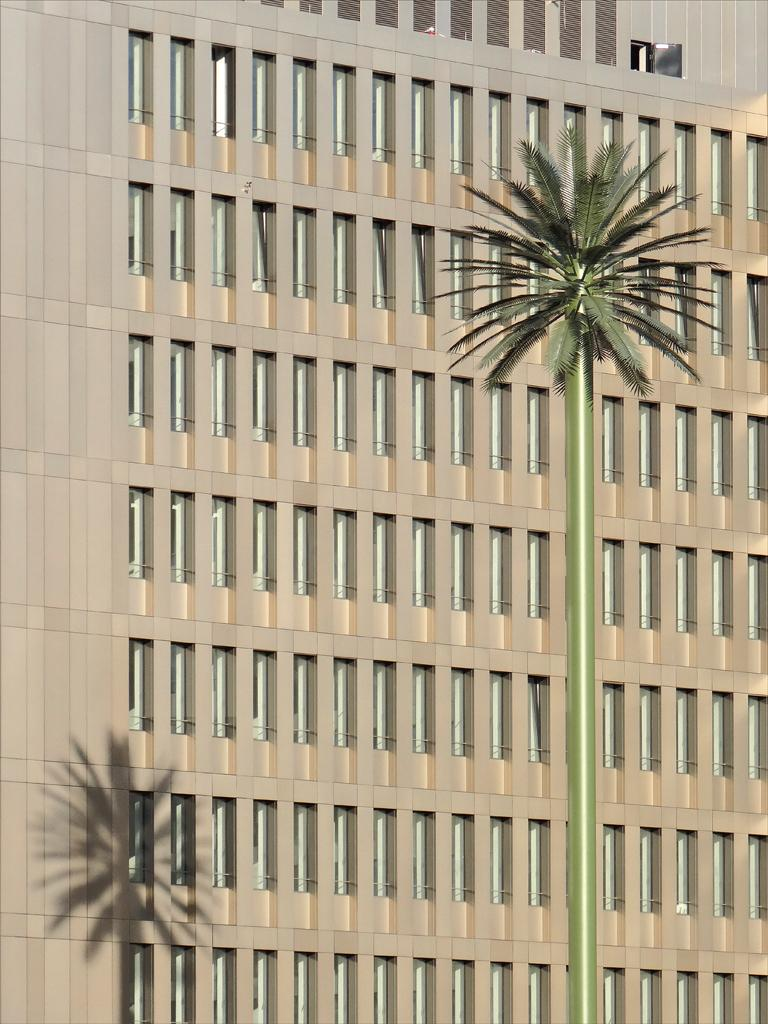What type of structure is visible in the image? There is a building in the image. What feature can be seen on the building? The building has windows. What is located in front of the building? There is a tree in front of the building. What can be observed on the left side of the building? There is a shadow on the left side of the building. What type of steel art can be seen on the right side of the building? There is no steel art present on the right side of the building in the image. 